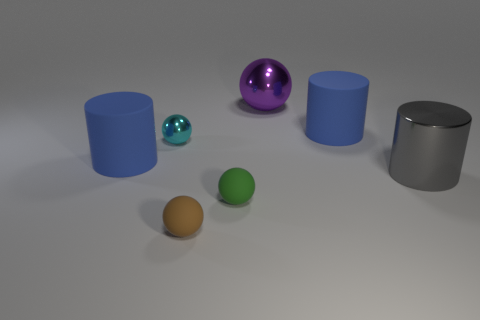Subtract 1 balls. How many balls are left? 3 Subtract all gray spheres. Subtract all yellow blocks. How many spheres are left? 4 Add 1 tiny purple balls. How many objects exist? 8 Subtract all balls. How many objects are left? 3 Add 4 tiny green rubber objects. How many tiny green rubber objects exist? 5 Subtract 1 gray cylinders. How many objects are left? 6 Subtract all small shiny objects. Subtract all blue things. How many objects are left? 4 Add 2 cylinders. How many cylinders are left? 5 